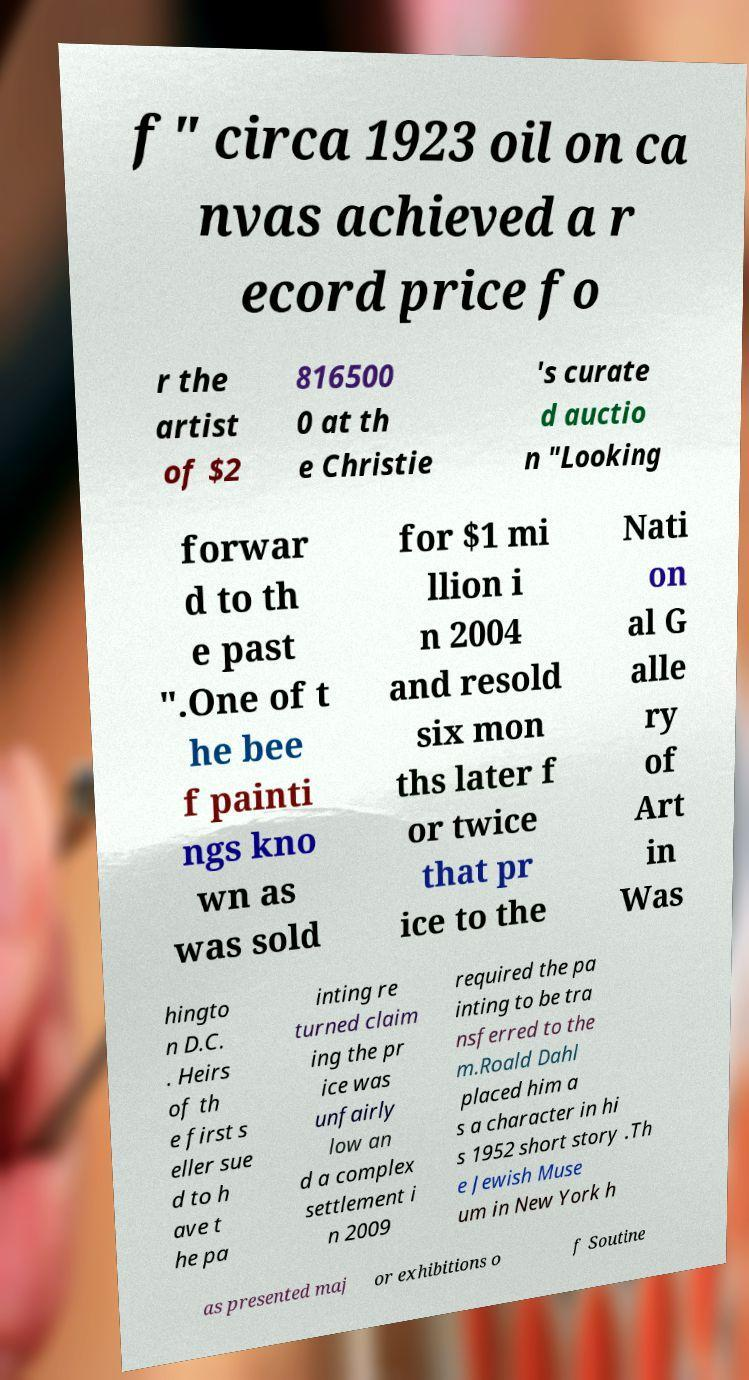Could you assist in decoding the text presented in this image and type it out clearly? f" circa 1923 oil on ca nvas achieved a r ecord price fo r the artist of $2 816500 0 at th e Christie 's curate d auctio n "Looking forwar d to th e past ".One of t he bee f painti ngs kno wn as was sold for $1 mi llion i n 2004 and resold six mon ths later f or twice that pr ice to the Nati on al G alle ry of Art in Was hingto n D.C. . Heirs of th e first s eller sue d to h ave t he pa inting re turned claim ing the pr ice was unfairly low an d a complex settlement i n 2009 required the pa inting to be tra nsferred to the m.Roald Dahl placed him a s a character in hi s 1952 short story .Th e Jewish Muse um in New York h as presented maj or exhibitions o f Soutine 